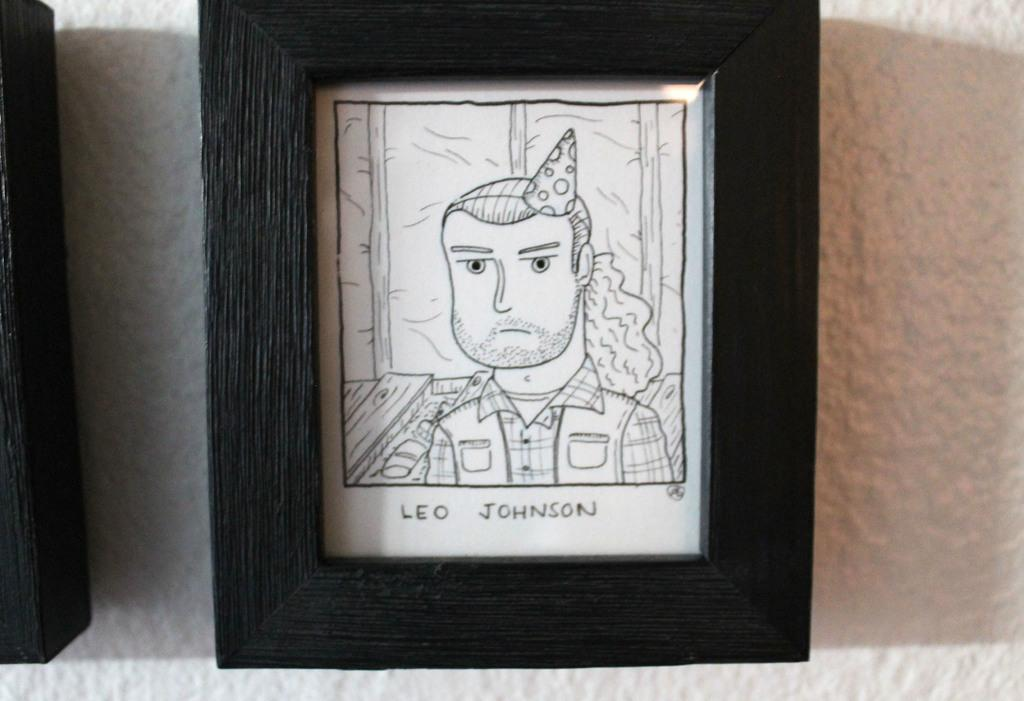<image>
Present a compact description of the photo's key features. A framed black and white cartoon depiction of Leo Johnson wearing a party hat. 